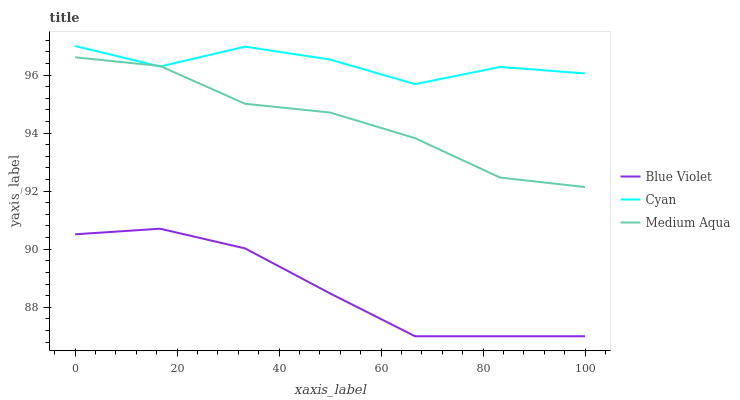Does Blue Violet have the minimum area under the curve?
Answer yes or no. Yes. Does Cyan have the maximum area under the curve?
Answer yes or no. Yes. Does Medium Aqua have the minimum area under the curve?
Answer yes or no. No. Does Medium Aqua have the maximum area under the curve?
Answer yes or no. No. Is Blue Violet the smoothest?
Answer yes or no. Yes. Is Cyan the roughest?
Answer yes or no. Yes. Is Medium Aqua the smoothest?
Answer yes or no. No. Is Medium Aqua the roughest?
Answer yes or no. No. Does Blue Violet have the lowest value?
Answer yes or no. Yes. Does Medium Aqua have the lowest value?
Answer yes or no. No. Does Cyan have the highest value?
Answer yes or no. Yes. Does Medium Aqua have the highest value?
Answer yes or no. No. Is Blue Violet less than Cyan?
Answer yes or no. Yes. Is Cyan greater than Blue Violet?
Answer yes or no. Yes. Does Medium Aqua intersect Cyan?
Answer yes or no. Yes. Is Medium Aqua less than Cyan?
Answer yes or no. No. Is Medium Aqua greater than Cyan?
Answer yes or no. No. Does Blue Violet intersect Cyan?
Answer yes or no. No. 